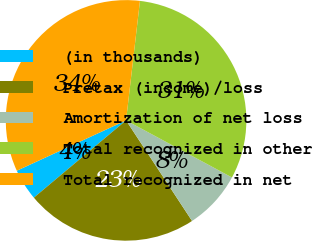Convert chart. <chart><loc_0><loc_0><loc_500><loc_500><pie_chart><fcel>(in thousands)<fcel>Pretax (income)/loss<fcel>Amortization of net loss<fcel>Total recognized in other<fcel>Total recognized in net<nl><fcel>4.23%<fcel>23.14%<fcel>7.89%<fcel>31.03%<fcel>33.72%<nl></chart> 